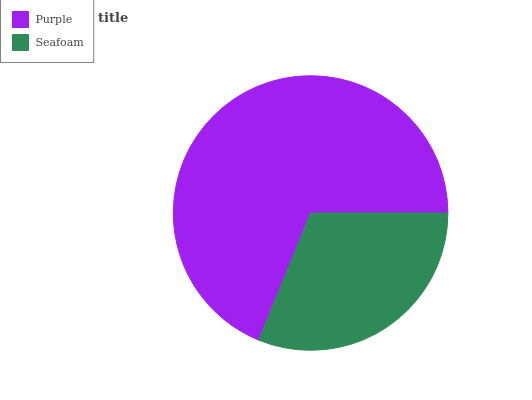Is Seafoam the minimum?
Answer yes or no. Yes. Is Purple the maximum?
Answer yes or no. Yes. Is Seafoam the maximum?
Answer yes or no. No. Is Purple greater than Seafoam?
Answer yes or no. Yes. Is Seafoam less than Purple?
Answer yes or no. Yes. Is Seafoam greater than Purple?
Answer yes or no. No. Is Purple less than Seafoam?
Answer yes or no. No. Is Purple the high median?
Answer yes or no. Yes. Is Seafoam the low median?
Answer yes or no. Yes. Is Seafoam the high median?
Answer yes or no. No. Is Purple the low median?
Answer yes or no. No. 